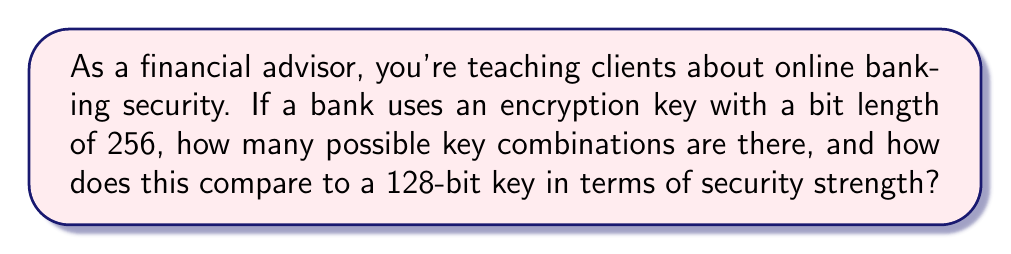What is the answer to this math problem? Let's approach this step-by-step:

1. For an n-bit key, the number of possible combinations is $2^n$.

2. For a 256-bit key:
   Number of combinations = $2^{256}$

3. For a 128-bit key:
   Number of combinations = $2^{128}$

4. To compare the security strength, we can divide the number of combinations:

   $\frac{2^{256}}{2^{128}} = 2^{256-128} = 2^{128}$

5. This means a 256-bit key has $2^{128}$ times more combinations than a 128-bit key.

6. To put this in perspective:
   $2^{128} \approx 3.4 \times 10^{38}$

7. This is an enormously large number, indicating that a 256-bit key is vastly more secure than a 128-bit key.

8. In practical terms, even with current supercomputers, brute-forcing a 128-bit key would take billions of years. A 256-bit key is exponentially more secure.
Answer: $2^{256}$ combinations; $2^{128}$ times stronger than 128-bit key 